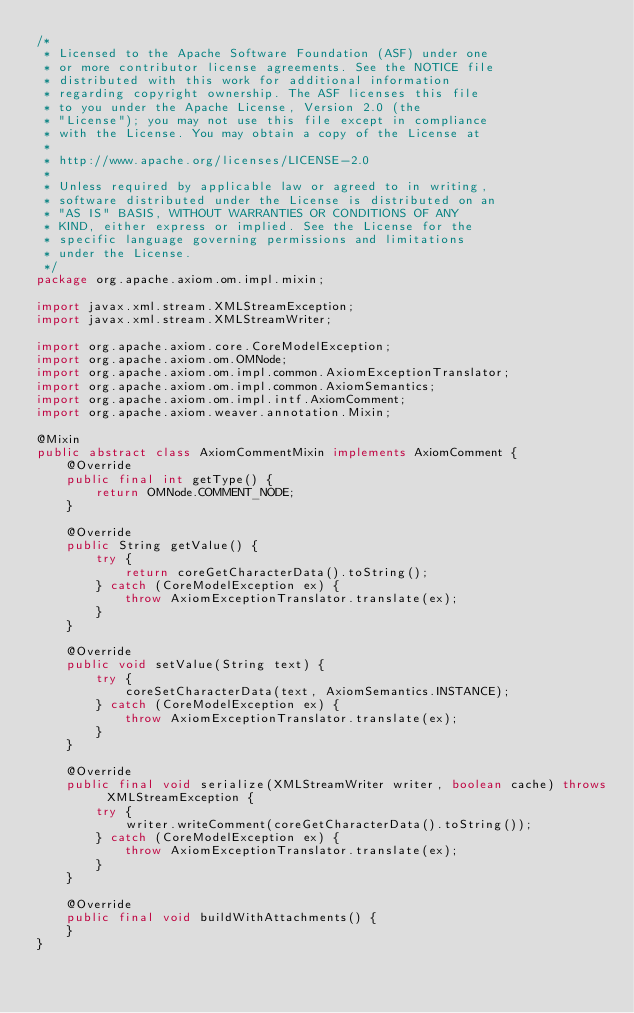Convert code to text. <code><loc_0><loc_0><loc_500><loc_500><_Java_>/*
 * Licensed to the Apache Software Foundation (ASF) under one
 * or more contributor license agreements. See the NOTICE file
 * distributed with this work for additional information
 * regarding copyright ownership. The ASF licenses this file
 * to you under the Apache License, Version 2.0 (the
 * "License"); you may not use this file except in compliance
 * with the License. You may obtain a copy of the License at
 *
 * http://www.apache.org/licenses/LICENSE-2.0
 *
 * Unless required by applicable law or agreed to in writing,
 * software distributed under the License is distributed on an
 * "AS IS" BASIS, WITHOUT WARRANTIES OR CONDITIONS OF ANY
 * KIND, either express or implied. See the License for the
 * specific language governing permissions and limitations
 * under the License.
 */
package org.apache.axiom.om.impl.mixin;

import javax.xml.stream.XMLStreamException;
import javax.xml.stream.XMLStreamWriter;

import org.apache.axiom.core.CoreModelException;
import org.apache.axiom.om.OMNode;
import org.apache.axiom.om.impl.common.AxiomExceptionTranslator;
import org.apache.axiom.om.impl.common.AxiomSemantics;
import org.apache.axiom.om.impl.intf.AxiomComment;
import org.apache.axiom.weaver.annotation.Mixin;

@Mixin
public abstract class AxiomCommentMixin implements AxiomComment {
    @Override
    public final int getType() {
        return OMNode.COMMENT_NODE;
    }

    @Override
    public String getValue() {
        try {
            return coreGetCharacterData().toString();
        } catch (CoreModelException ex) {
            throw AxiomExceptionTranslator.translate(ex);
        }
    }

    @Override
    public void setValue(String text) {
        try {
            coreSetCharacterData(text, AxiomSemantics.INSTANCE);
        } catch (CoreModelException ex) {
            throw AxiomExceptionTranslator.translate(ex);
        }
    }

    @Override
    public final void serialize(XMLStreamWriter writer, boolean cache) throws XMLStreamException {
        try {
            writer.writeComment(coreGetCharacterData().toString());
        } catch (CoreModelException ex) {
            throw AxiomExceptionTranslator.translate(ex);
        }
    }
    
    @Override
    public final void buildWithAttachments() {
    }
}
</code> 